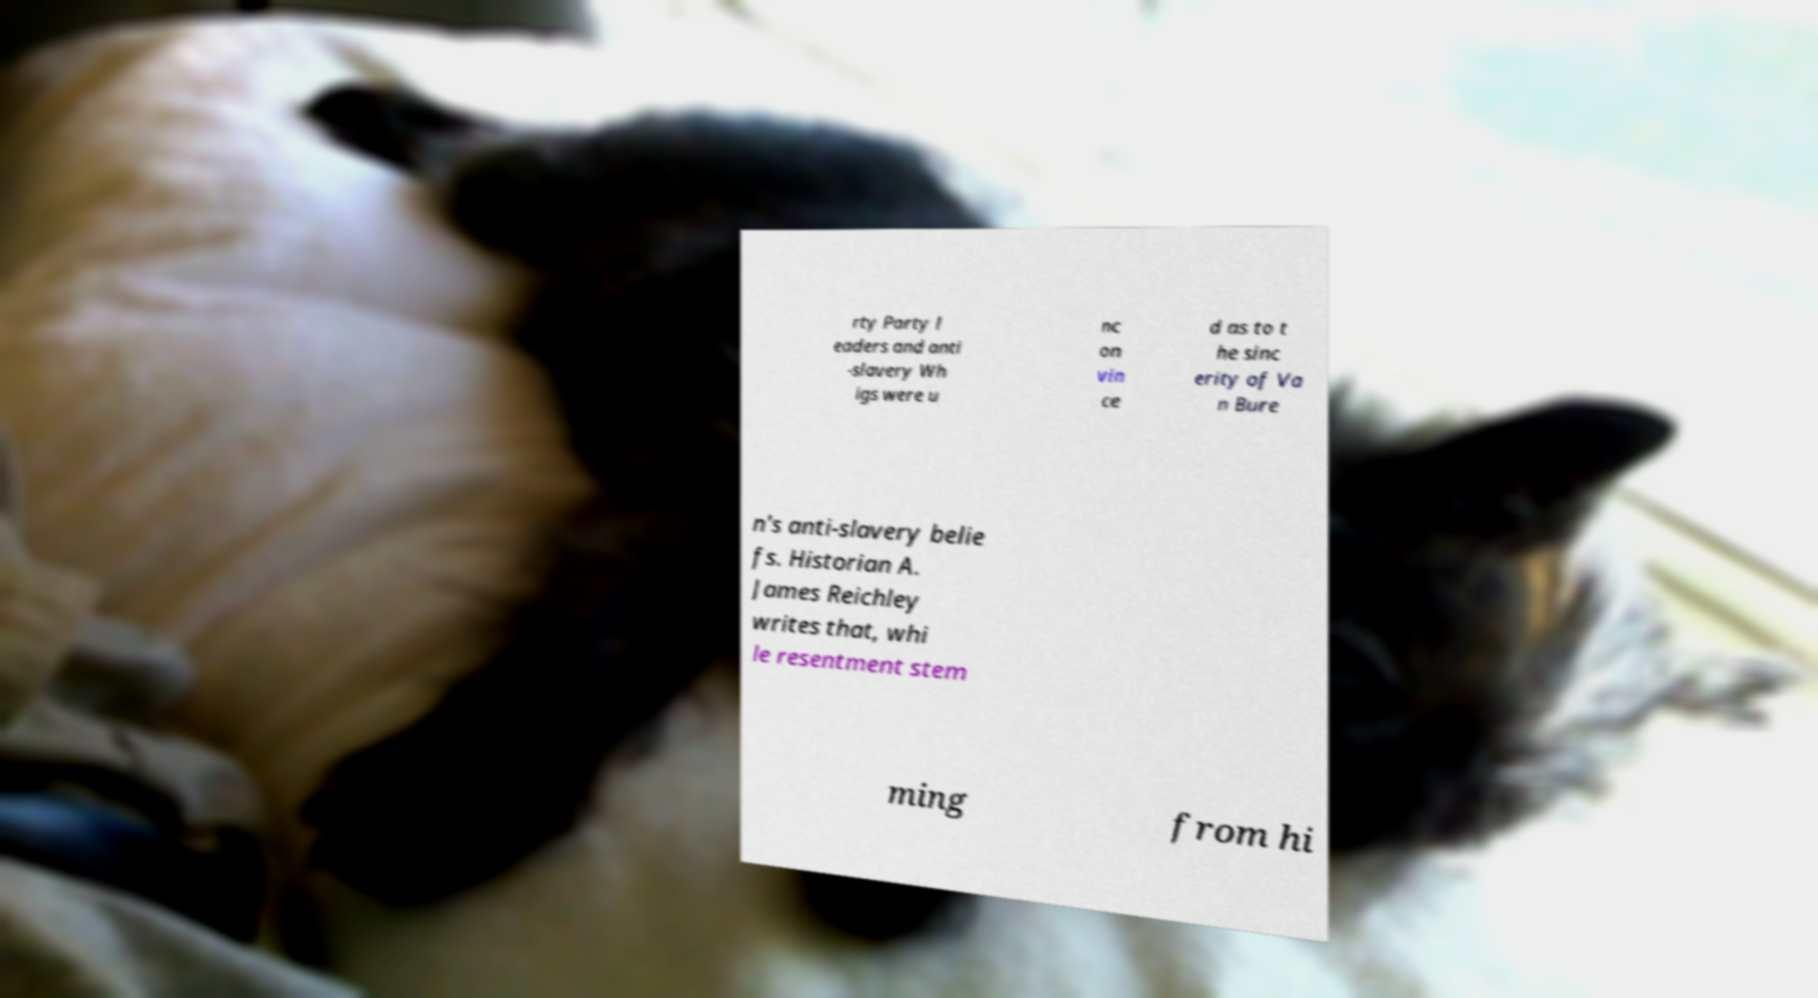Can you accurately transcribe the text from the provided image for me? rty Party l eaders and anti -slavery Wh igs were u nc on vin ce d as to t he sinc erity of Va n Bure n's anti-slavery belie fs. Historian A. James Reichley writes that, whi le resentment stem ming from hi 